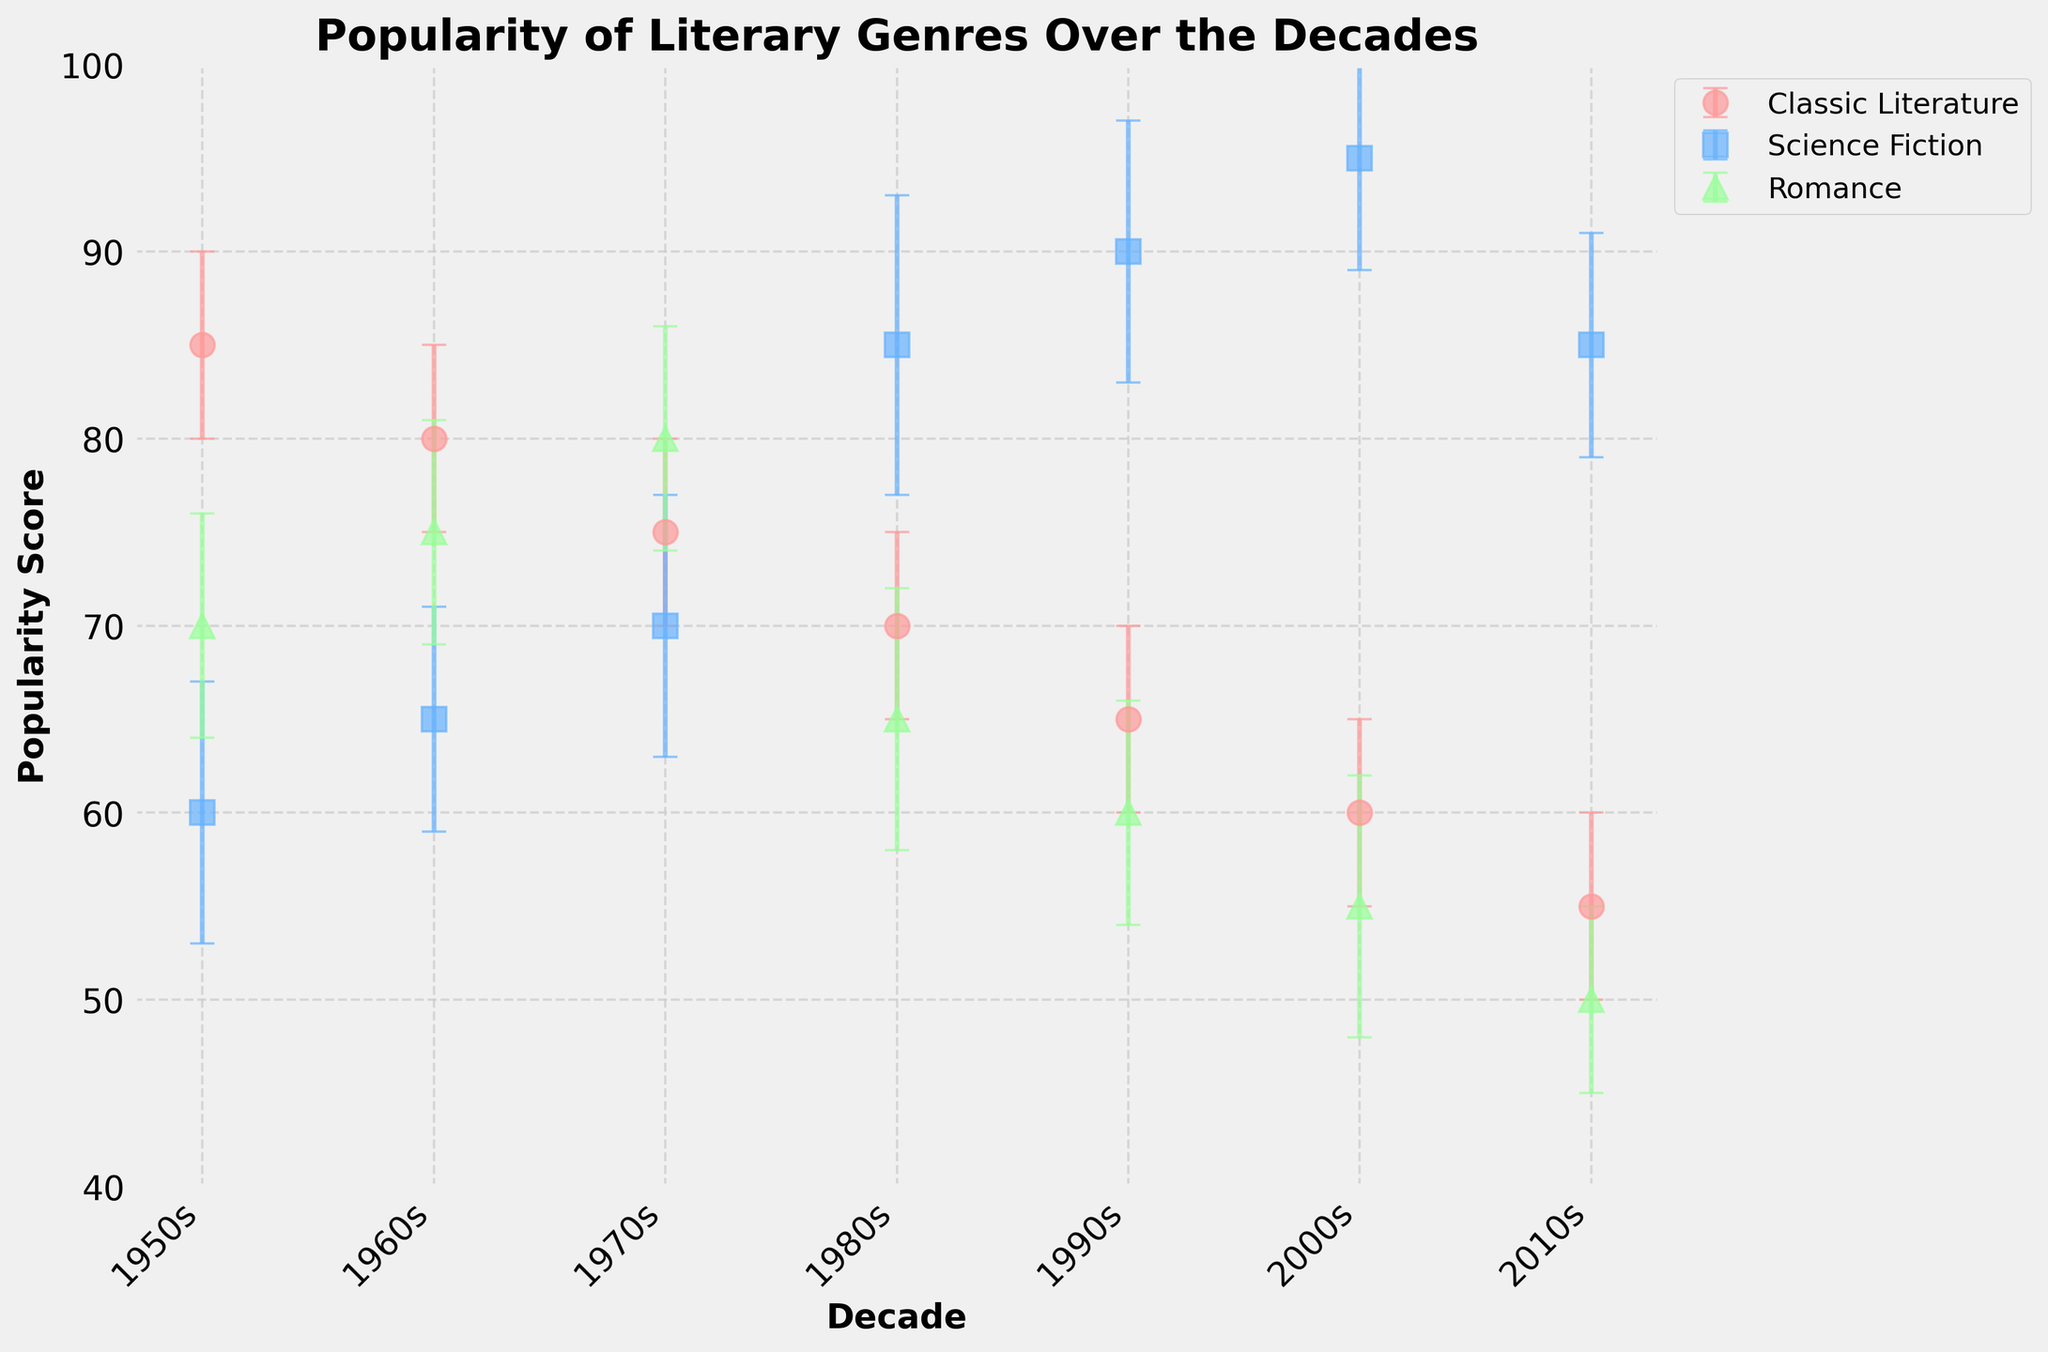What is the title of the figure? The title is usually found at the top center of the plot. It gives a brief summary of what the figure represents.
Answer: Popularity of Literary Genres Over the Decades What are the genres represented in the plot? By examining the legend of the plot, which uses different colors and markers for different genres, you can identify the genres.
Answer: Classic Literature, Science Fiction, Romance Which decade has the highest popularity score for Science Fiction? To find this, you look for the point with the highest y-value among the Science Fiction data points, which are usually in a consistent color/marker.
Answer: 2000s What is the general trend of the popularity score of Classic Literature from the 1950s to the 2010s? Examine the y-values (popularity scores) for Classic Literature across the decades. Note if they increase, decrease, or remain stable.
Answer: Decreasing Which genre had the highest error margin in the 1980s? By looking at the error bars in the 1980s data points, identify the genre with the largest error bar for that decade.
Answer: Science Fiction What's the difference in the popularity score of Romance between the 1950s and the 2010s? Locate the y-values for Romance in the 1950s and the 2010s and subtract the 2010s value from the 1950s value.
Answer: 20 During which decade did Science Fiction see the most significant increase in popularity score? Compare the popularity scores of Science Fiction across all consecutive decades to identify the largest increase.
Answer: 1980s Across which decades does Classic Literature maintain the same error margin? Check the y-values of the error bars for Classic Literature and see in which decades they remain the same.
Answer: All decades (1950s to 2010s) What is the average popularity score of all genres in the 1970s? Add the popularity scores of all genres in the 1970s, then divide by the number of genres (3). Calculation: (75 + 70 + 80) / 3
Answer: 75 Considering the error margins, which genre's popularity score is the most uncertain in the 1990s? By comparing the sizes of the error bars for each genre in the 1990s, identify the largest one.
Answer: Science Fiction 